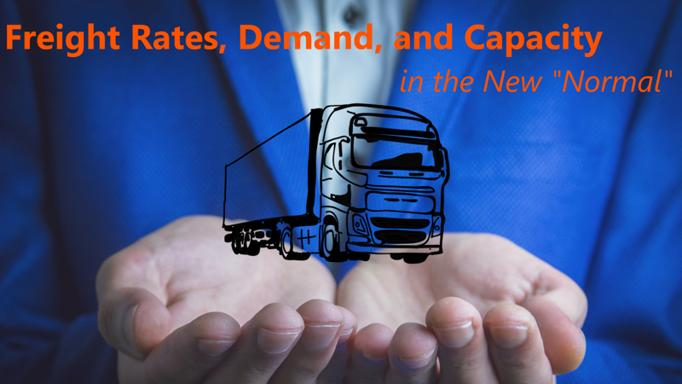What is the image text discussing in relation to the trucking industry? The image text titled 'Freight Rates, Demand, and Capacity in the New Normal' delves into how the trucking industry has had to adapt to recent economic upheavals and global events. It discusses the volatile nature of freight rates, fluctuating demand patterns among consumers and industries, and how companies are managing their fleet capacities to remain competitive and efficient in an ever-changing market landscape. 